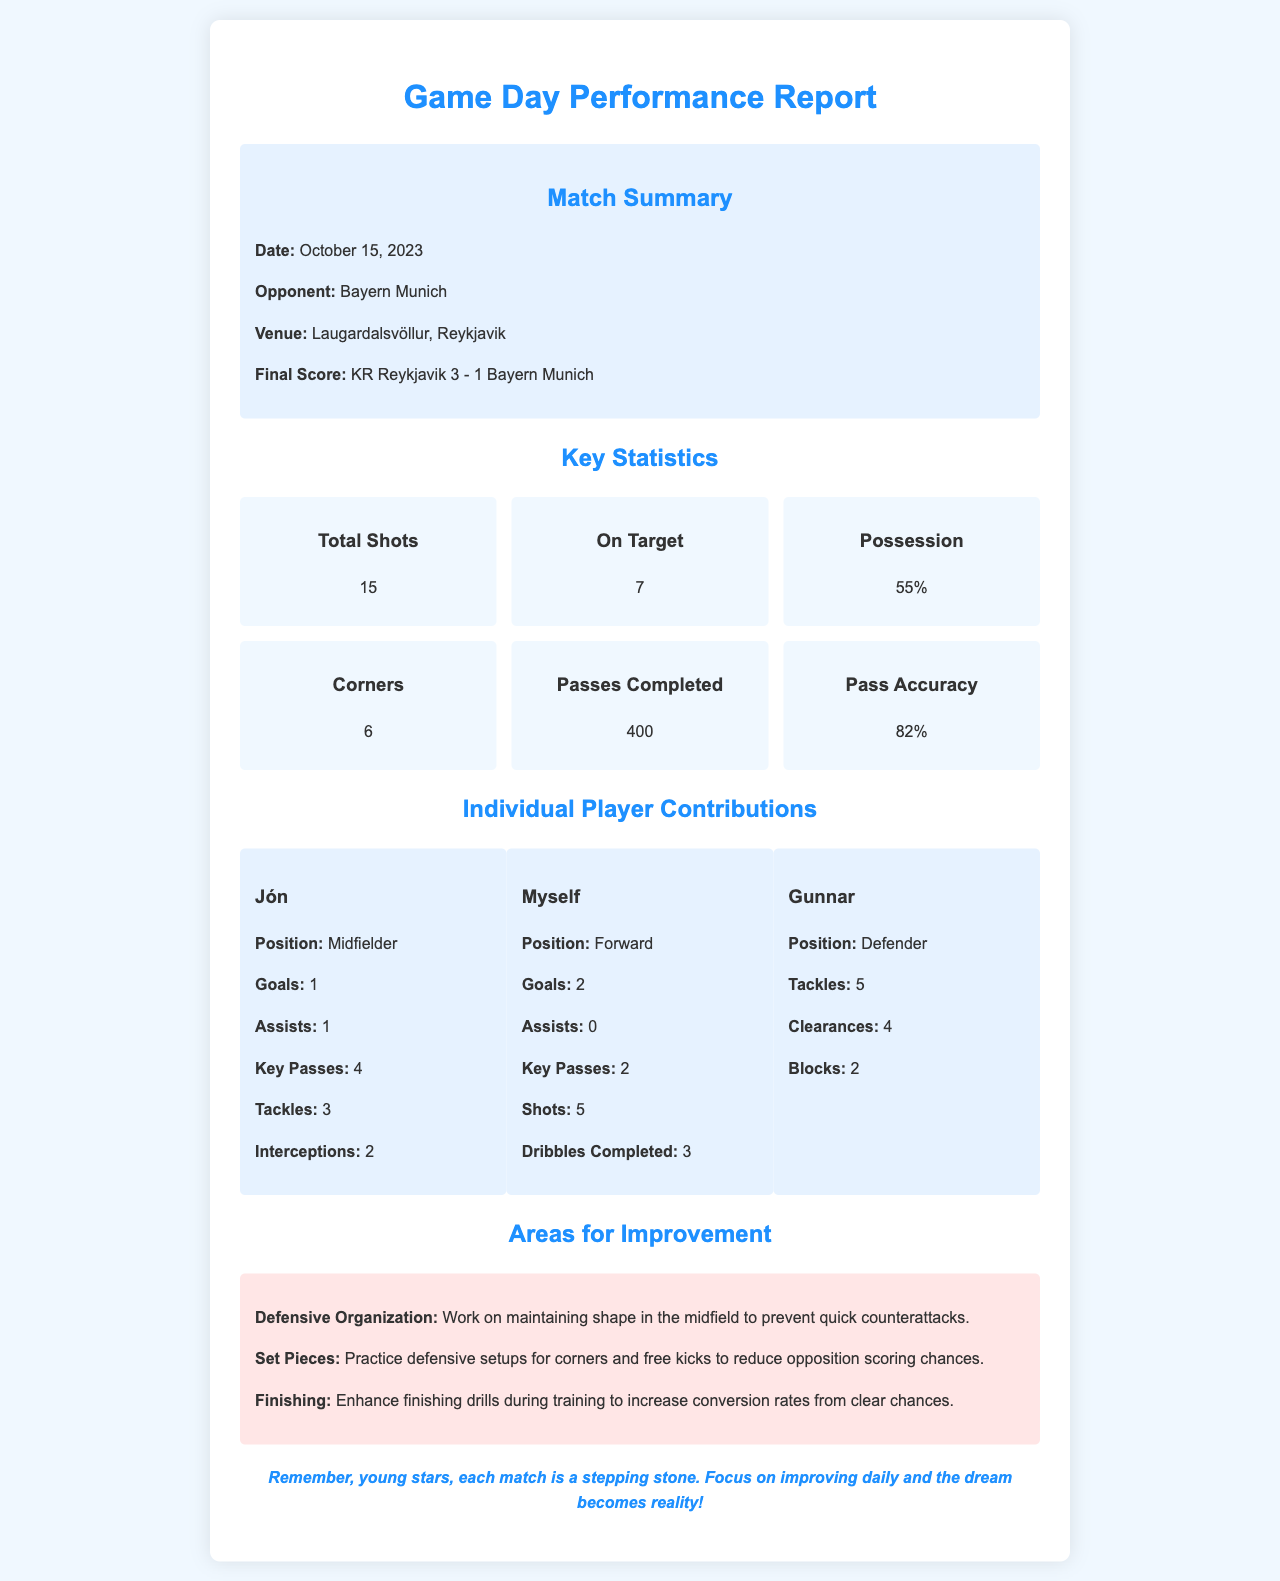What is the final score of the match? The final score is KR Reykjavik 3 - 1 Bayern Munich, as indicated in the match summary section of the document.
Answer: KR Reykjavik 3 - 1 Bayern Munich Who scored the goals for myself? The document lists my contributions, stating that I scored 2 goals in the match.
Answer: 2 What was the possession percentage for KR Reykjavik? The possession statistic presented shows that KR Reykjavik held 55% of the possession during the match.
Answer: 55% How many key passes did Jón make? In the individual player contributions, it is noted that Jón made 4 key passes during the match.
Answer: 4 What area for improvement is mentioned regarding finishing? The document identifies "Finishing" as an area for improvement, highlighting the need to enhance finishing drills during training.
Answer: Finishing Which player provided an assist? According to the stats provided, Jón recorded 1 assist during the match, making him the player who assisted.
Answer: Jón How many total shots did KR Reykjavik take? The document indicates that the total number of shots taken by KR Reykjavik was 15.
Answer: 15 What date did the match take place? The match took place on October 15, 2023, as mentioned in the match summary section.
Answer: October 15, 2023 What is the venue of the match? The venue for the match is stated as Laugardalsvöllur, Reykjavik, in the summary.
Answer: Laugardalsvöllur, Reykjavik 